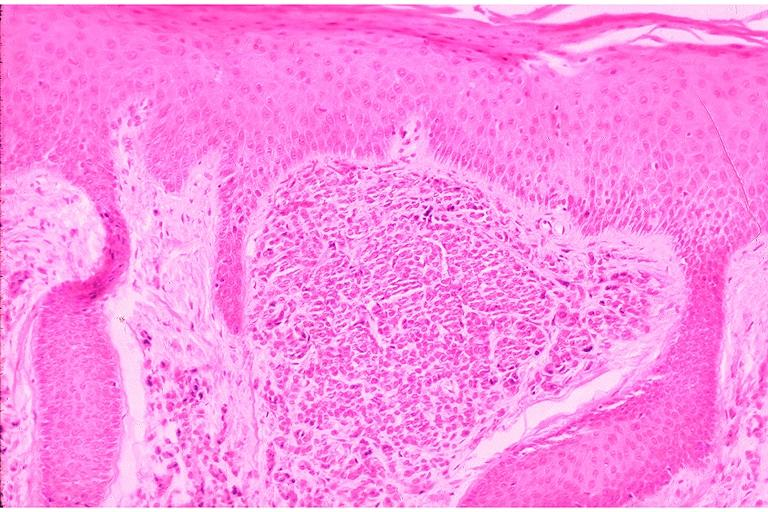what does this image show?
Answer the question using a single word or phrase. Intramucosal nevus 